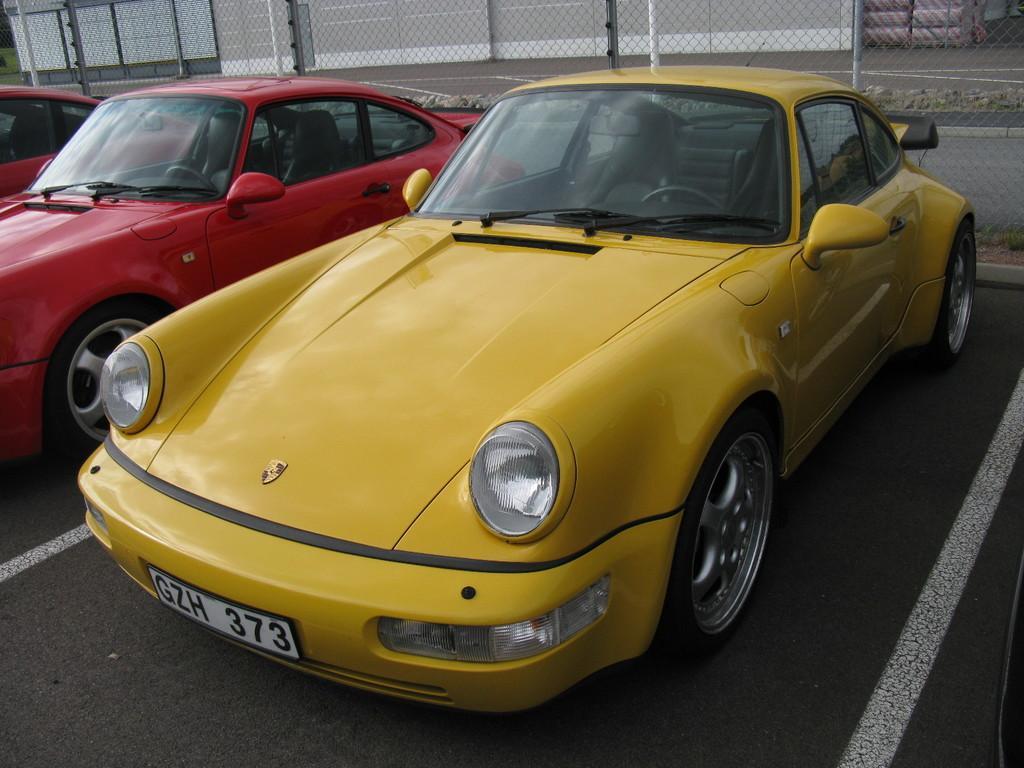How would you summarize this image in a sentence or two? In the image there is a yellow car and two red cars on the road and behind there is a fence. 